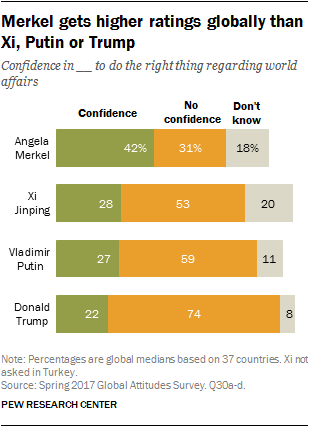Specify some key components in this picture. The total value of the last two green bars is 0.49. The color of the leftmost bars is green. 